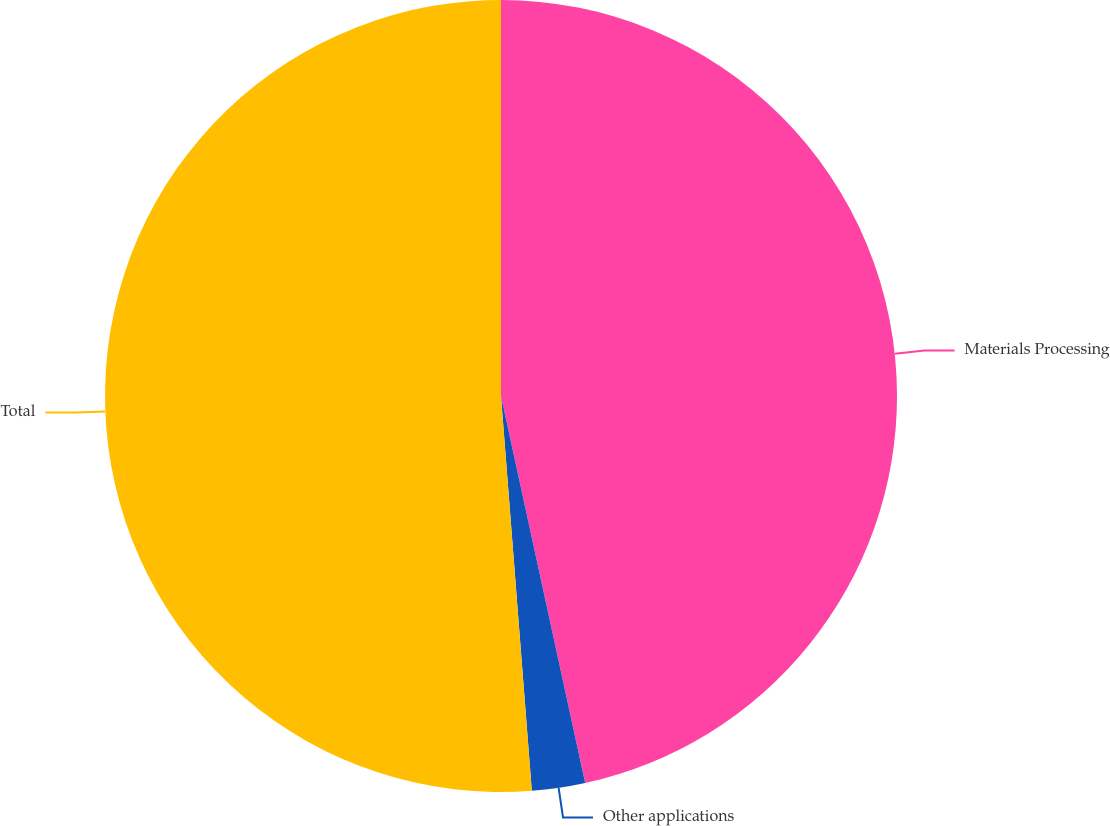<chart> <loc_0><loc_0><loc_500><loc_500><pie_chart><fcel>Materials Processing<fcel>Other applications<fcel>Total<nl><fcel>46.59%<fcel>2.17%<fcel>51.24%<nl></chart> 